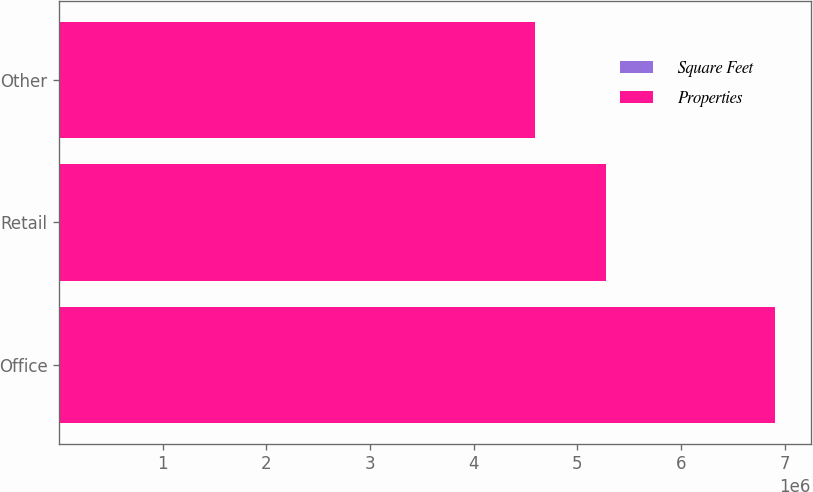Convert chart. <chart><loc_0><loc_0><loc_500><loc_500><stacked_bar_chart><ecel><fcel>Office<fcel>Retail<fcel>Other<nl><fcel>Square Feet<fcel>36<fcel>148<fcel>19<nl><fcel>Properties<fcel>6.909e+06<fcel>5.274e+06<fcel>4.592e+06<nl></chart> 